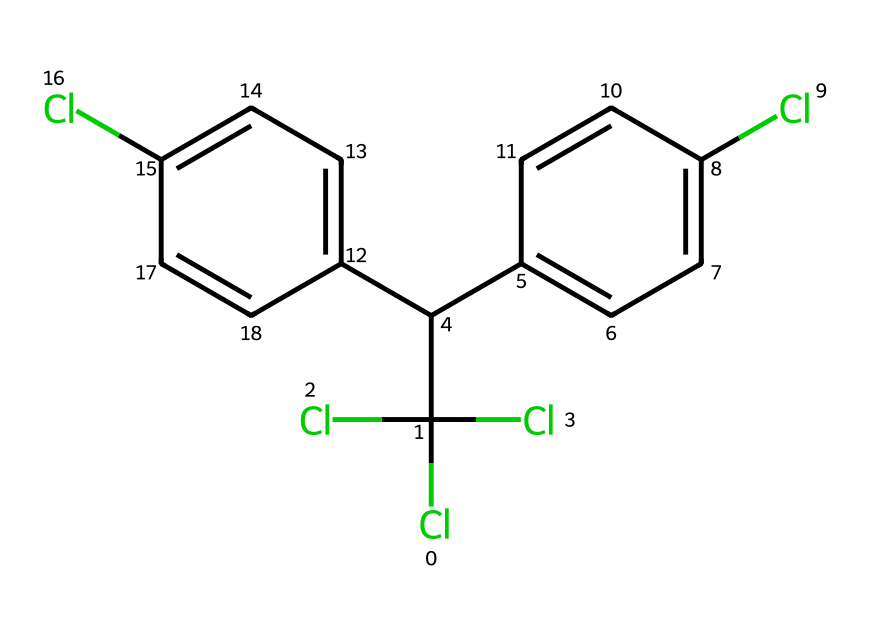How many chlorine atoms are present in this molecule? The structural formula indicates the presence of multiple chlorine atoms attached to the carbon framework. Counting the chlorine symbols yields a total of four.
Answer: 4 What type of compound is represented by this SMILES notation? The presence of multiple chlorine atoms attached to biphenyl suggests that this compound is a pesticide, specifically a chlorinated organic compound known as DDT.
Answer: pesticide What is the molecular formula for this compound? By analyzing the SMILES representation, we can deduce the number of each type of atom present. There are 14 carbons, 8 hydrogens, and 4 chlorines, which gives us the formula C14H9Cl4.
Answer: C14H9Cl4 Which features indicate the persistence of this pesticide in the environment? The extensive chlorination leads to high stability and resistance to biodegradation, particularly within the aromatic rings, making it persistent in the environment.
Answer: high stability How many aromatic rings are present in this structure? Examining the structure, there are two distinct benzene rings recognized by their alternating double bonds within the overall molecular framework.
Answer: 2 What is a significant environmental concern regarding DDT? DDT is known for its bioaccumulation in the food chain and potential to disrupt endocrine functions in wildlife and humans, leading to ecological and health problems.
Answer: bioaccumulation 